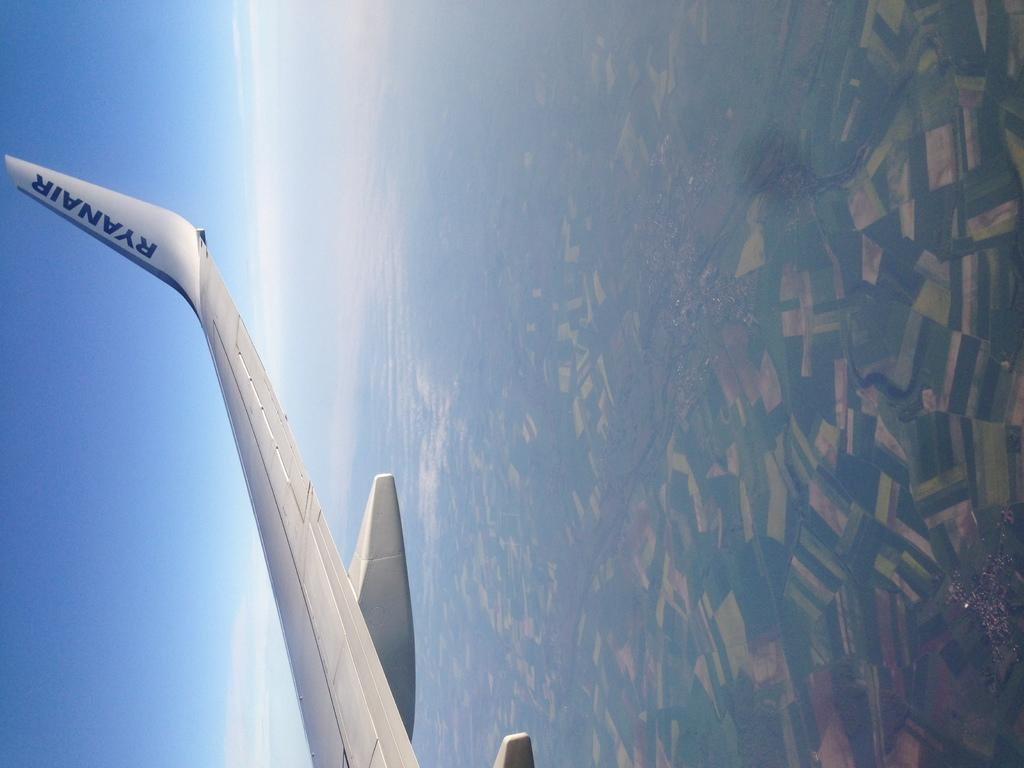<image>
Summarize the visual content of the image. The edge of an aircraft wing identifies it as belonging to Ryanair. 